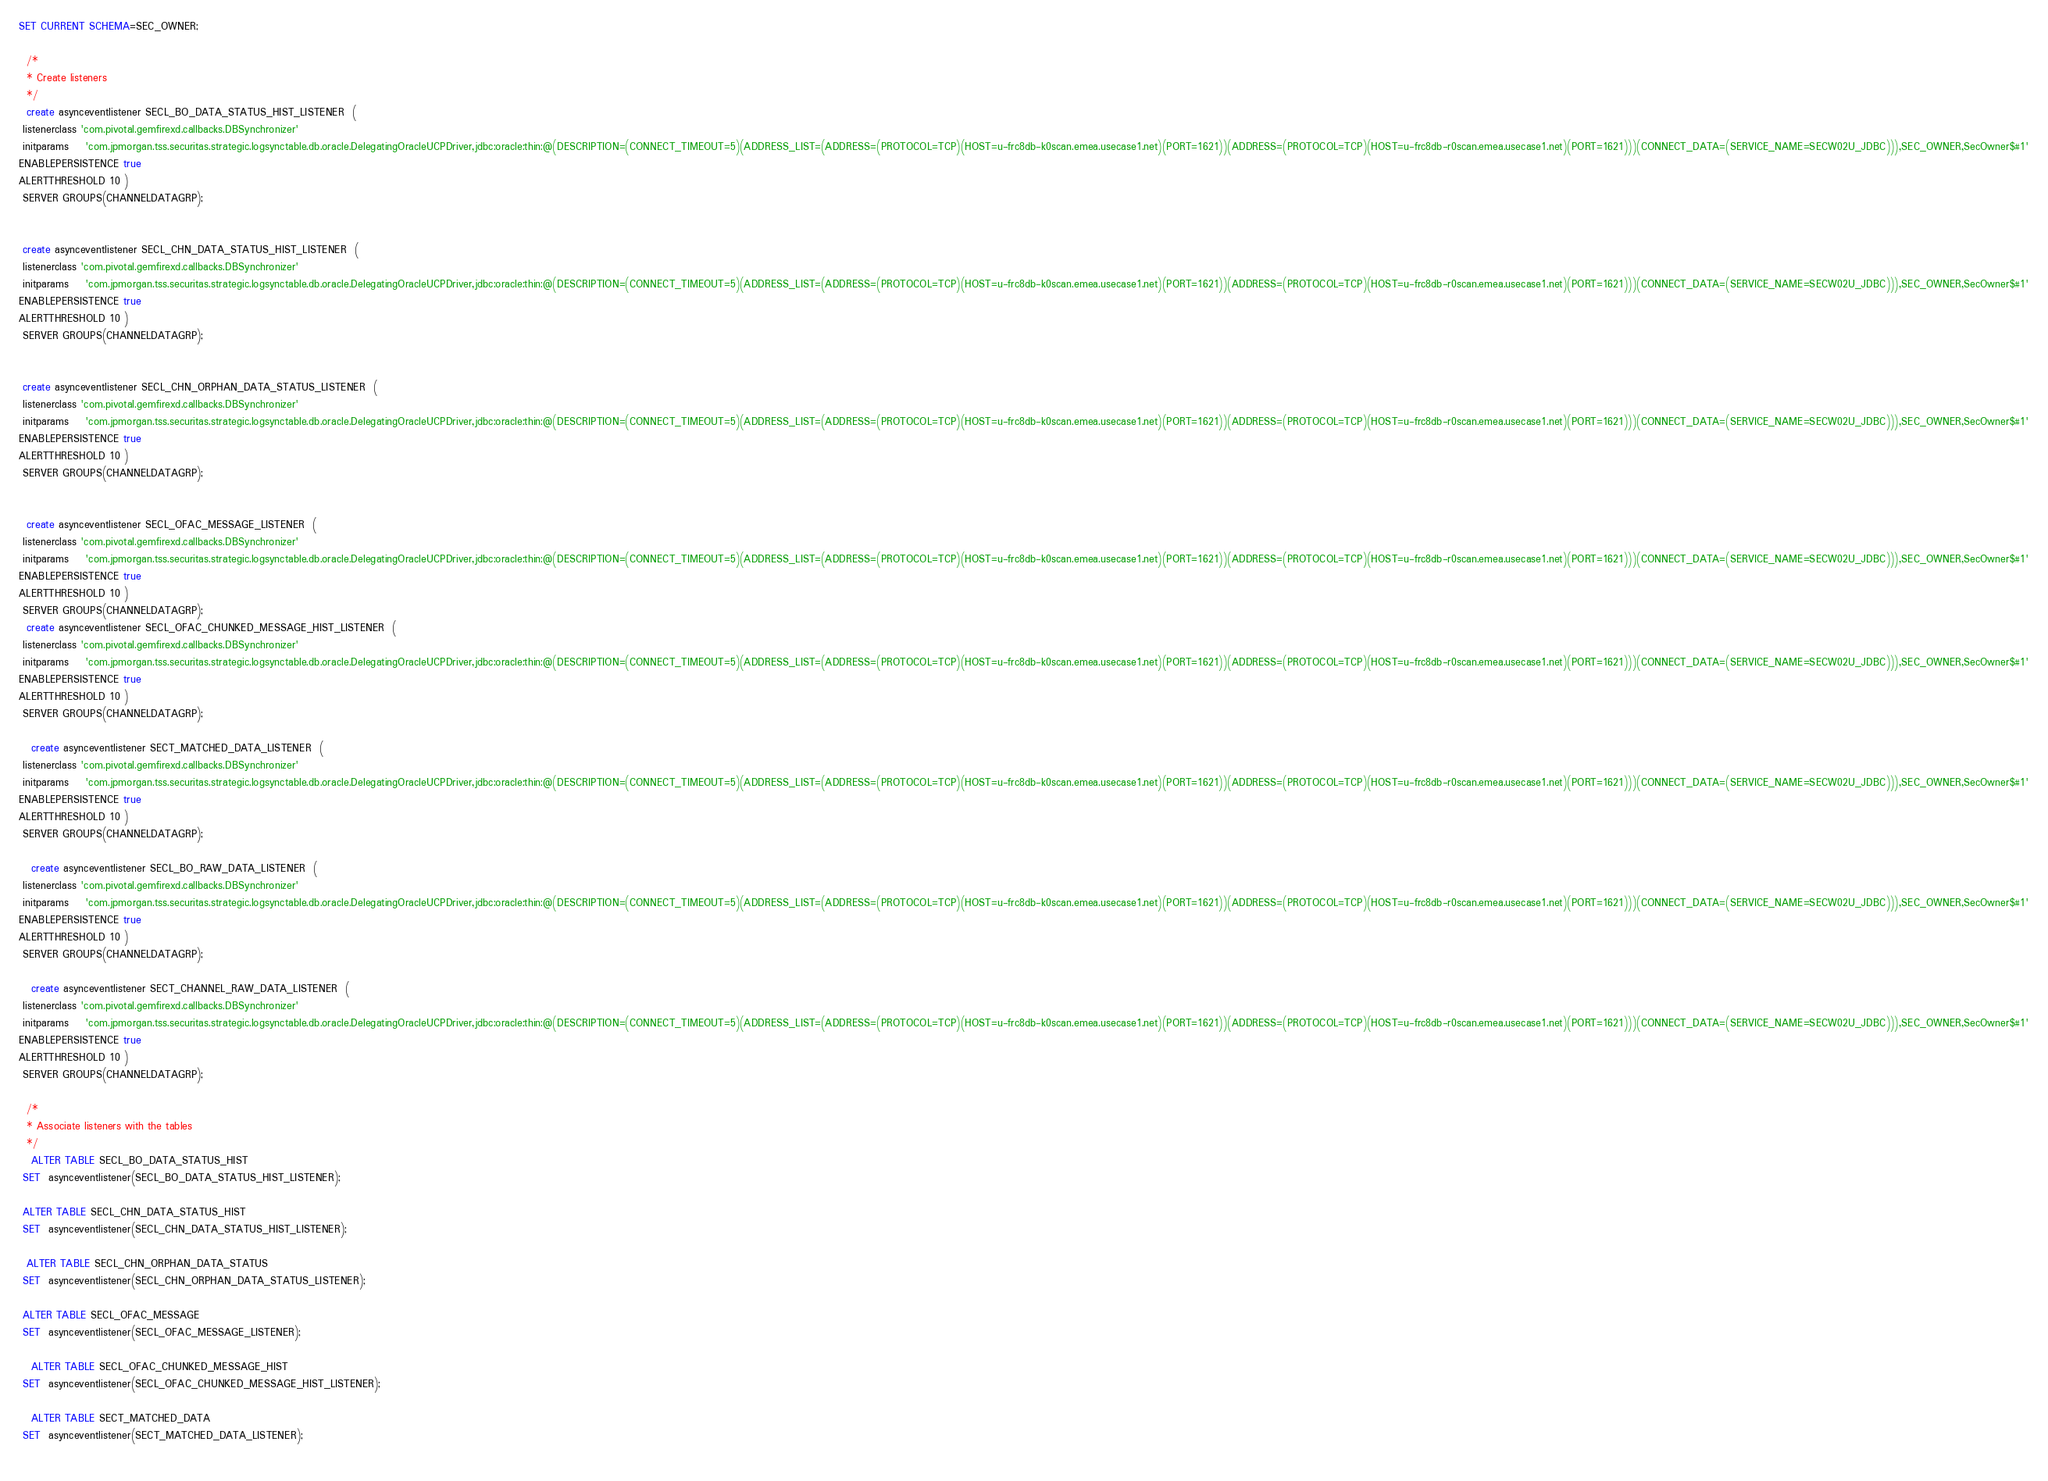Convert code to text. <code><loc_0><loc_0><loc_500><loc_500><_SQL_>SET CURRENT SCHEMA=SEC_OWNER;

  /*
  * Create listeners
  */ 
  create asynceventlistener SECL_BO_DATA_STATUS_HIST_LISTENER  (
 listenerclass 'com.pivotal.gemfirexd.callbacks.DBSynchronizer' 
 initparams    'com.jpmorgan.tss.securitas.strategic.logsynctable.db.oracle.DelegatingOracleUCPDriver,jdbc:oracle:thin:@(DESCRIPTION=(CONNECT_TIMEOUT=5)(ADDRESS_LIST=(ADDRESS=(PROTOCOL=TCP)(HOST=u-frc8db-k0scan.emea.usecase1.net)(PORT=1621))(ADDRESS=(PROTOCOL=TCP)(HOST=u-frc8db-r0scan.emea.usecase1.net)(PORT=1621)))(CONNECT_DATA=(SERVICE_NAME=SECW02U_JDBC))),SEC_OWNER,SecOwner$#1'
ENABLEPERSISTENCE true
ALERTTHRESHOLD 10 )
 SERVER GROUPS(CHANNELDATAGRP);
 
 
 create asynceventlistener SECL_CHN_DATA_STATUS_HIST_LISTENER  (
 listenerclass 'com.pivotal.gemfirexd.callbacks.DBSynchronizer' 
 initparams    'com.jpmorgan.tss.securitas.strategic.logsynctable.db.oracle.DelegatingOracleUCPDriver,jdbc:oracle:thin:@(DESCRIPTION=(CONNECT_TIMEOUT=5)(ADDRESS_LIST=(ADDRESS=(PROTOCOL=TCP)(HOST=u-frc8db-k0scan.emea.usecase1.net)(PORT=1621))(ADDRESS=(PROTOCOL=TCP)(HOST=u-frc8db-r0scan.emea.usecase1.net)(PORT=1621)))(CONNECT_DATA=(SERVICE_NAME=SECW02U_JDBC))),SEC_OWNER,SecOwner$#1'
ENABLEPERSISTENCE true
ALERTTHRESHOLD 10 )
 SERVER GROUPS(CHANNELDATAGRP);
 
 
 create asynceventlistener SECL_CHN_ORPHAN_DATA_STATUS_LISTENER  (
 listenerclass 'com.pivotal.gemfirexd.callbacks.DBSynchronizer' 
 initparams    'com.jpmorgan.tss.securitas.strategic.logsynctable.db.oracle.DelegatingOracleUCPDriver,jdbc:oracle:thin:@(DESCRIPTION=(CONNECT_TIMEOUT=5)(ADDRESS_LIST=(ADDRESS=(PROTOCOL=TCP)(HOST=u-frc8db-k0scan.emea.usecase1.net)(PORT=1621))(ADDRESS=(PROTOCOL=TCP)(HOST=u-frc8db-r0scan.emea.usecase1.net)(PORT=1621)))(CONNECT_DATA=(SERVICE_NAME=SECW02U_JDBC))),SEC_OWNER,SecOwner$#1'
ENABLEPERSISTENCE true
ALERTTHRESHOLD 10 )
 SERVER GROUPS(CHANNELDATAGRP);
 
 
  create asynceventlistener SECL_OFAC_MESSAGE_LISTENER  (
 listenerclass 'com.pivotal.gemfirexd.callbacks.DBSynchronizer' 
 initparams    'com.jpmorgan.tss.securitas.strategic.logsynctable.db.oracle.DelegatingOracleUCPDriver,jdbc:oracle:thin:@(DESCRIPTION=(CONNECT_TIMEOUT=5)(ADDRESS_LIST=(ADDRESS=(PROTOCOL=TCP)(HOST=u-frc8db-k0scan.emea.usecase1.net)(PORT=1621))(ADDRESS=(PROTOCOL=TCP)(HOST=u-frc8db-r0scan.emea.usecase1.net)(PORT=1621)))(CONNECT_DATA=(SERVICE_NAME=SECW02U_JDBC))),SEC_OWNER,SecOwner$#1'
ENABLEPERSISTENCE true
ALERTTHRESHOLD 10 )
 SERVER GROUPS(CHANNELDATAGRP);
  create asynceventlistener SECL_OFAC_CHUNKED_MESSAGE_HIST_LISTENER  (
 listenerclass 'com.pivotal.gemfirexd.callbacks.DBSynchronizer' 
 initparams    'com.jpmorgan.tss.securitas.strategic.logsynctable.db.oracle.DelegatingOracleUCPDriver,jdbc:oracle:thin:@(DESCRIPTION=(CONNECT_TIMEOUT=5)(ADDRESS_LIST=(ADDRESS=(PROTOCOL=TCP)(HOST=u-frc8db-k0scan.emea.usecase1.net)(PORT=1621))(ADDRESS=(PROTOCOL=TCP)(HOST=u-frc8db-r0scan.emea.usecase1.net)(PORT=1621)))(CONNECT_DATA=(SERVICE_NAME=SECW02U_JDBC))),SEC_OWNER,SecOwner$#1'
ENABLEPERSISTENCE true
ALERTTHRESHOLD 10 )
 SERVER GROUPS(CHANNELDATAGRP); 
 
   create asynceventlistener SECT_MATCHED_DATA_LISTENER  (
 listenerclass 'com.pivotal.gemfirexd.callbacks.DBSynchronizer' 
 initparams    'com.jpmorgan.tss.securitas.strategic.logsynctable.db.oracle.DelegatingOracleUCPDriver,jdbc:oracle:thin:@(DESCRIPTION=(CONNECT_TIMEOUT=5)(ADDRESS_LIST=(ADDRESS=(PROTOCOL=TCP)(HOST=u-frc8db-k0scan.emea.usecase1.net)(PORT=1621))(ADDRESS=(PROTOCOL=TCP)(HOST=u-frc8db-r0scan.emea.usecase1.net)(PORT=1621)))(CONNECT_DATA=(SERVICE_NAME=SECW02U_JDBC))),SEC_OWNER,SecOwner$#1'
ENABLEPERSISTENCE true
ALERTTHRESHOLD 10 )
 SERVER GROUPS(CHANNELDATAGRP); 
 
   create asynceventlistener SECL_BO_RAW_DATA_LISTENER  (
 listenerclass 'com.pivotal.gemfirexd.callbacks.DBSynchronizer' 
 initparams    'com.jpmorgan.tss.securitas.strategic.logsynctable.db.oracle.DelegatingOracleUCPDriver,jdbc:oracle:thin:@(DESCRIPTION=(CONNECT_TIMEOUT=5)(ADDRESS_LIST=(ADDRESS=(PROTOCOL=TCP)(HOST=u-frc8db-k0scan.emea.usecase1.net)(PORT=1621))(ADDRESS=(PROTOCOL=TCP)(HOST=u-frc8db-r0scan.emea.usecase1.net)(PORT=1621)))(CONNECT_DATA=(SERVICE_NAME=SECW02U_JDBC))),SEC_OWNER,SecOwner$#1'
ENABLEPERSISTENCE true
ALERTTHRESHOLD 10 )
 SERVER GROUPS(CHANNELDATAGRP); 
 
   create asynceventlistener SECT_CHANNEL_RAW_DATA_LISTENER  (
 listenerclass 'com.pivotal.gemfirexd.callbacks.DBSynchronizer' 
 initparams    'com.jpmorgan.tss.securitas.strategic.logsynctable.db.oracle.DelegatingOracleUCPDriver,jdbc:oracle:thin:@(DESCRIPTION=(CONNECT_TIMEOUT=5)(ADDRESS_LIST=(ADDRESS=(PROTOCOL=TCP)(HOST=u-frc8db-k0scan.emea.usecase1.net)(PORT=1621))(ADDRESS=(PROTOCOL=TCP)(HOST=u-frc8db-r0scan.emea.usecase1.net)(PORT=1621)))(CONNECT_DATA=(SERVICE_NAME=SECW02U_JDBC))),SEC_OWNER,SecOwner$#1'
ENABLEPERSISTENCE true
ALERTTHRESHOLD 10 )
 SERVER GROUPS(CHANNELDATAGRP); 
 
  /*
  * Associate listeners with the tables
  */ 
   ALTER TABLE SECL_BO_DATA_STATUS_HIST 
 SET  asynceventlistener(SECL_BO_DATA_STATUS_HIST_LISTENER);
 
 ALTER TABLE SECL_CHN_DATA_STATUS_HIST 
 SET  asynceventlistener(SECL_CHN_DATA_STATUS_HIST_LISTENER);
 
  ALTER TABLE SECL_CHN_ORPHAN_DATA_STATUS 
 SET  asynceventlistener(SECL_CHN_ORPHAN_DATA_STATUS_LISTENER);
 
 ALTER TABLE SECL_OFAC_MESSAGE 
 SET  asynceventlistener(SECL_OFAC_MESSAGE_LISTENER);
 
   ALTER TABLE SECL_OFAC_CHUNKED_MESSAGE_HIST 
 SET  asynceventlistener(SECL_OFAC_CHUNKED_MESSAGE_HIST_LISTENER);
 
   ALTER TABLE SECT_MATCHED_DATA 
 SET  asynceventlistener(SECT_MATCHED_DATA_LISTENER);
 </code> 